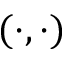<formula> <loc_0><loc_0><loc_500><loc_500>( \cdot , \cdot )</formula> 